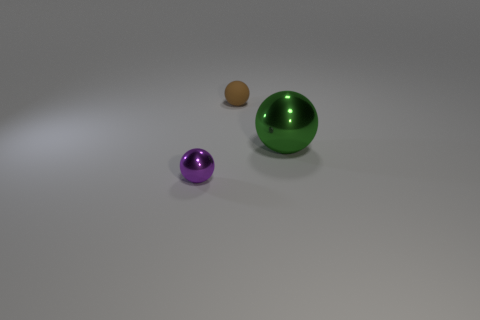Subtract 1 spheres. How many spheres are left? 2 Add 1 tiny yellow shiny things. How many objects exist? 4 Subtract 0 yellow cylinders. How many objects are left? 3 Subtract all small blue rubber blocks. Subtract all tiny purple spheres. How many objects are left? 2 Add 2 metal objects. How many metal objects are left? 4 Add 2 purple shiny objects. How many purple shiny objects exist? 3 